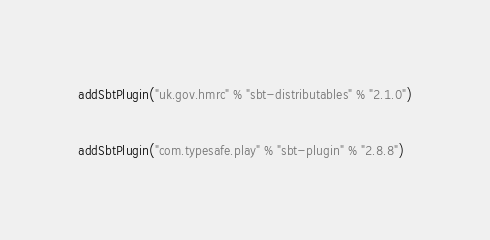<code> <loc_0><loc_0><loc_500><loc_500><_Scala_>addSbtPlugin("uk.gov.hmrc" % "sbt-distributables" % "2.1.0")

addSbtPlugin("com.typesafe.play" % "sbt-plugin" % "2.8.8")
</code> 